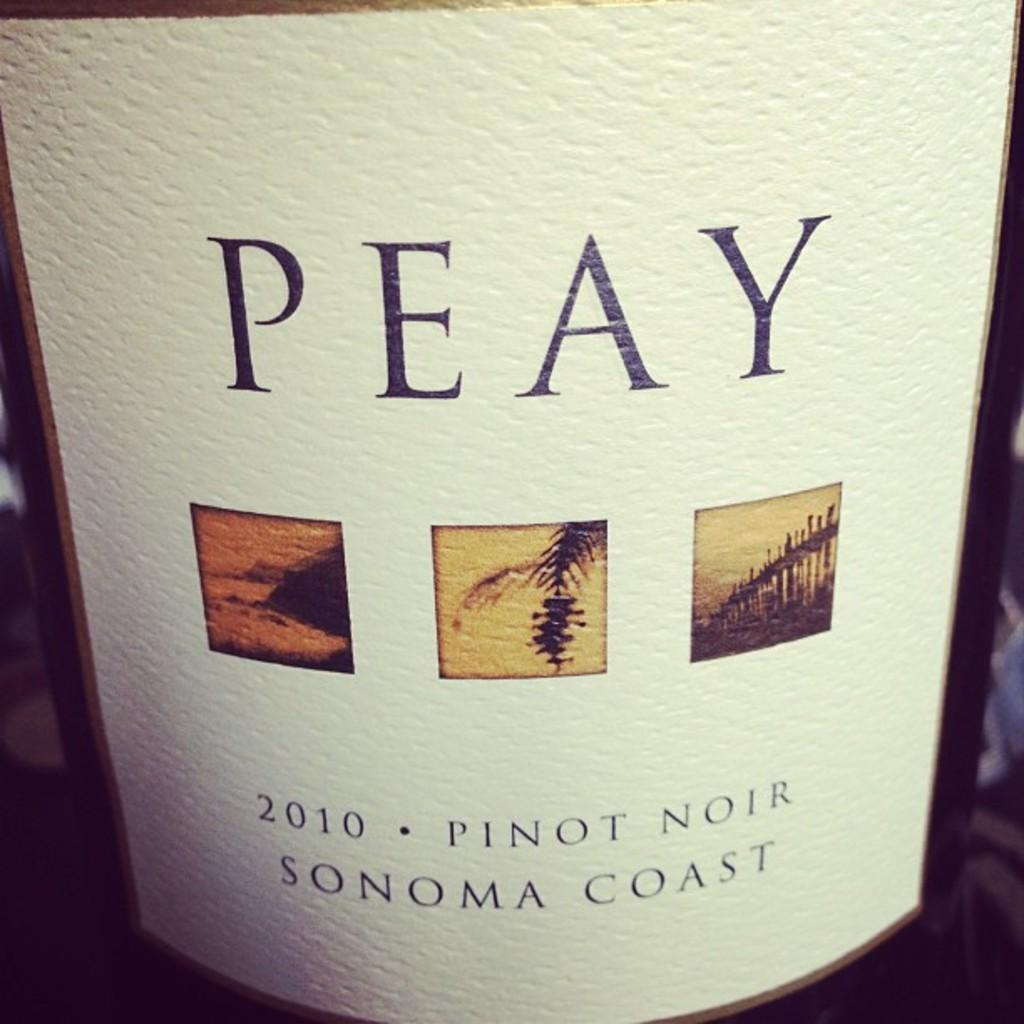<image>
Render a clear and concise summary of the photo. Wine bottle with a label that says PEAY. 